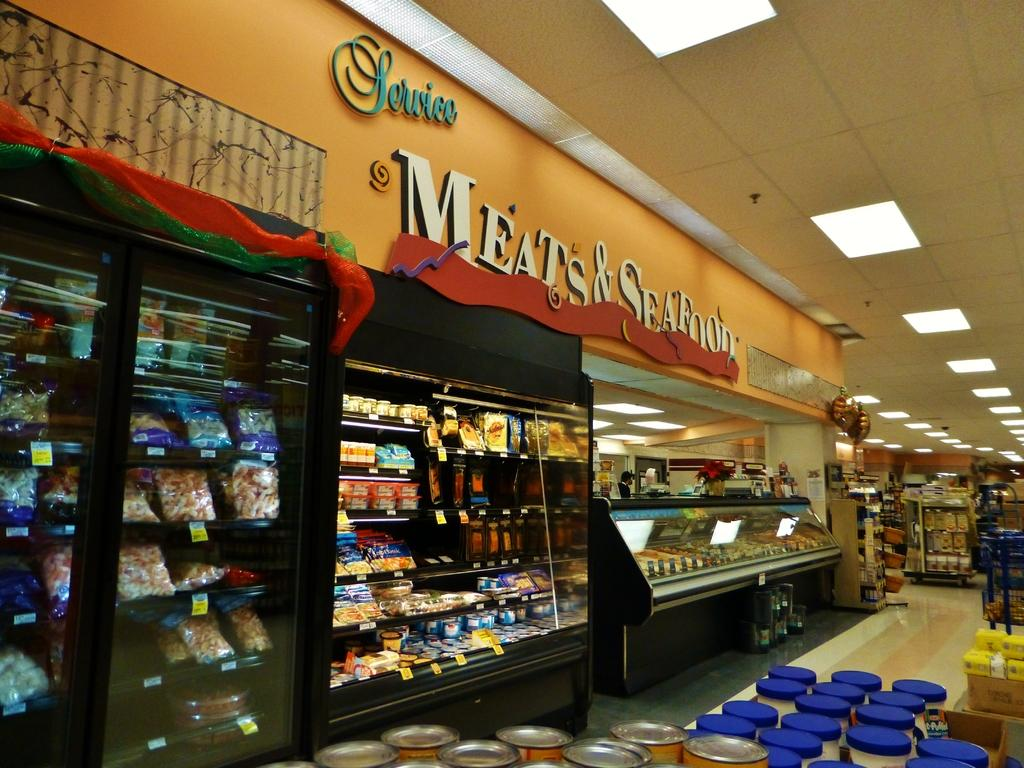<image>
Offer a succinct explanation of the picture presented. The frozen food section of a supermarket and wall says Service and Meat and Seafood. 